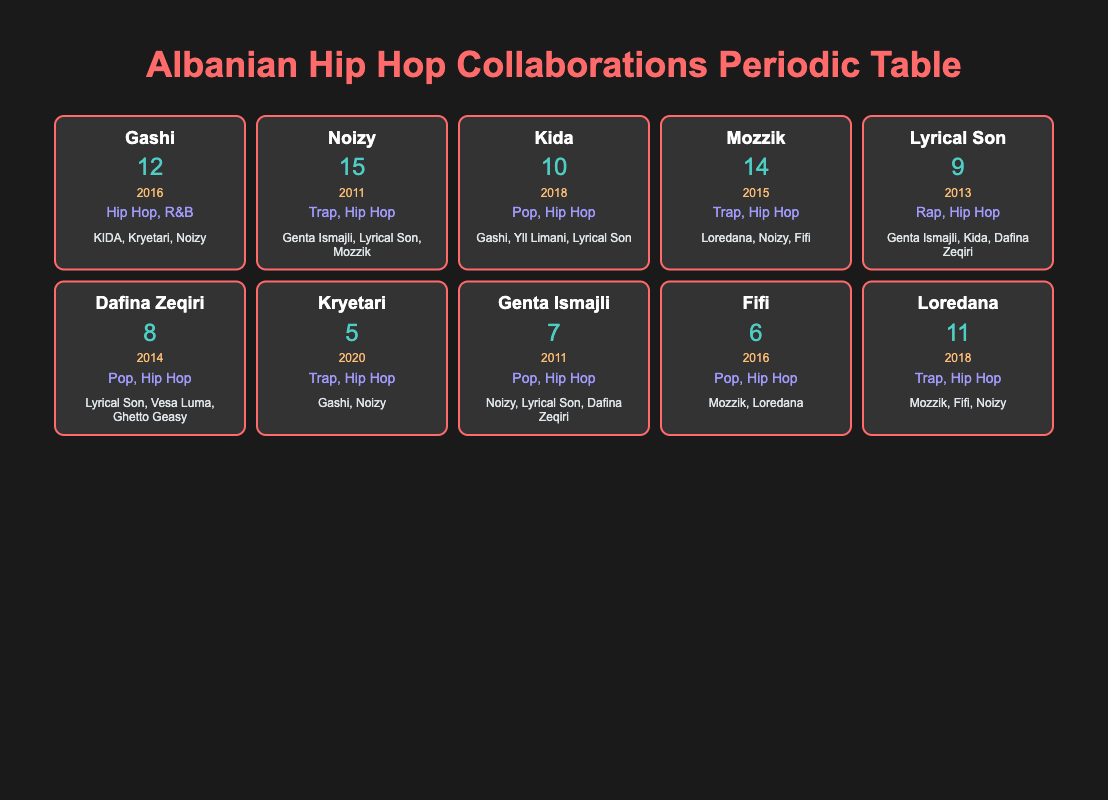What is the total number of collaborations by Noizy? According to the table, Noizy has made 15 collaborations listed under the "Collaborations" column.
Answer: 15 Which artist has the least number of collaborations? The table shows that Kryetari has the least collaborations with only 5 listed.
Answer: Kryetari How many collaborations does Gashi have compared to Kida? Gashi has 12 collaborations, and Kida has 10. The difference is 12 - 10 = 2. Thus, Gashi has 2 more collaborations than Kida.
Answer: 2 Is it true that Lyrical Son has more collaborations than Dafina Zeqiri? Lyrical Son has 9 collaborations, while Dafina Zeqiri has 8, confirming that Lyrical Son indeed has more collaborations than Dafina.
Answer: Yes What is the average number of collaborations among the artists listed? To find the average, add all the collaborations (12 + 15 + 10 + 14 + 9 + 8 + 5 + 7 + 6 + 11 =  107) and divide by the number of artists (10). Thus, the average is 107 / 10 = 10.7.
Answer: 10.7 Which artist debuted first among the top three in collaboration numbers? The top three artists are Noizy (2011), Mozzik (2015), and Gashi (2016). Comparing the debut years, Noizy debuted first in 2011.
Answer: Noizy How many artists have 10 or more collaborations? The artists with 10 or more collaborations are Noizy (15), Gashi (12), Mozzik (14), Kida (10), and Loredana (11). That gives a total of 5 artists.
Answer: 5 Who collaborated with both Gashi and Noizy? The artist that collaborated with both Gashi and Noizy is Kryetari. This is confirmed by looking at the "Notable Collabs" for Kryetari.
Answer: Kryetari What styles do the artists with the highest number of collaborations (Noizy) represent? Noizy represents Trap and Hip Hop styles as listed in the "Style" column.
Answer: Trap, Hip Hop 